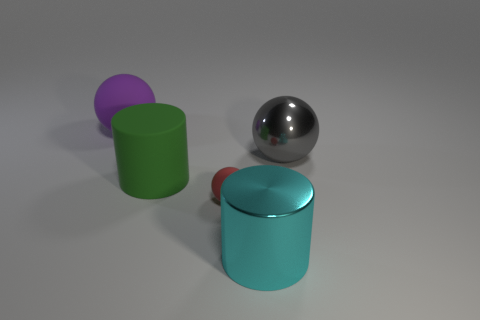Subtract all red balls. How many balls are left? 2 Add 3 large purple balls. How many objects exist? 8 Subtract all spheres. How many objects are left? 2 Add 1 large gray objects. How many large gray objects exist? 2 Subtract 1 purple balls. How many objects are left? 4 Subtract all blue spheres. Subtract all red cylinders. How many spheres are left? 3 Subtract all cyan shiny objects. Subtract all large cyan metallic cylinders. How many objects are left? 3 Add 2 shiny things. How many shiny things are left? 4 